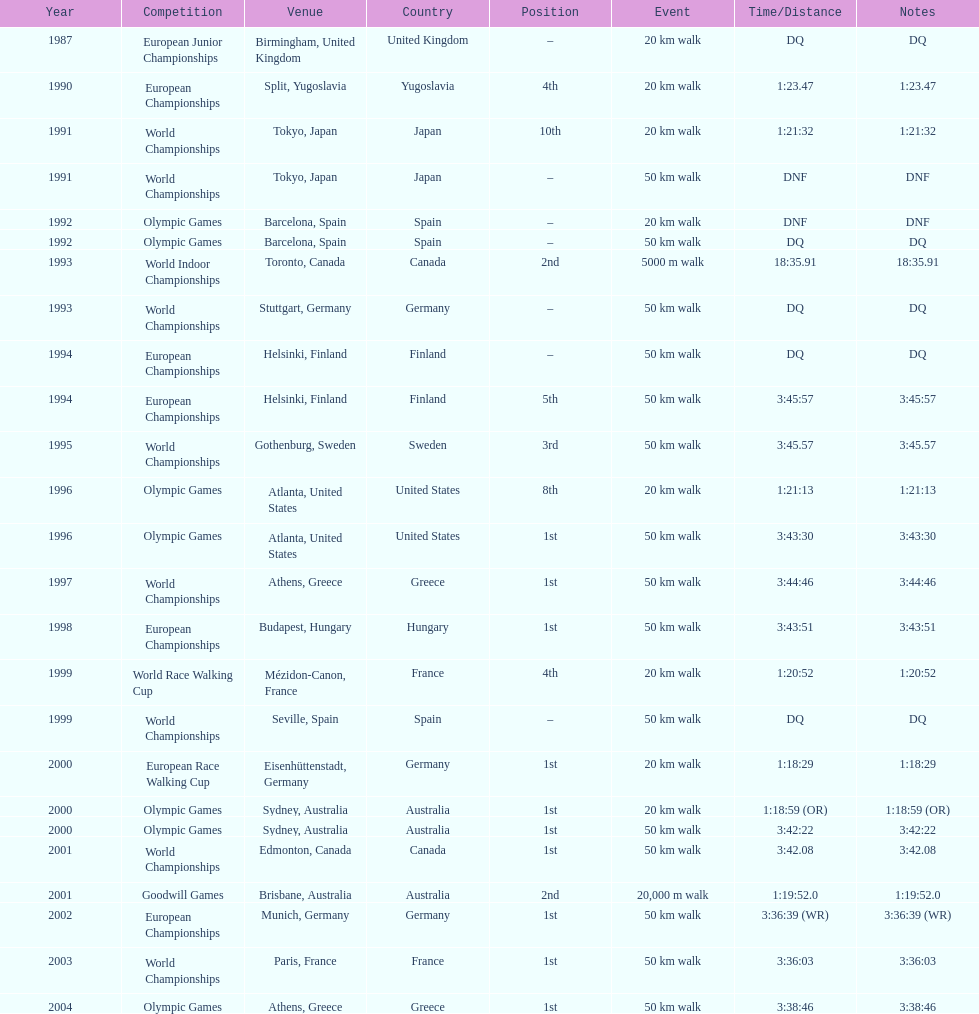What are the notes DQ, 1:23.47, 1:21:32, DNF, DNF, DQ, 18:35.91, DQ, DQ, 3:45:57, 3:45.57, 1:21:13, 3:43:30, 3:44:46, 3:43:51, 1:20:52, DQ, 1:18:29, 1:18:59 (OR), 3:42:22, 3:42.08, 1:19:52.0, 3:36:39 (WR), 3:36:03, 3:38:46. What time does the notes for 2004 show 3:38:46. 